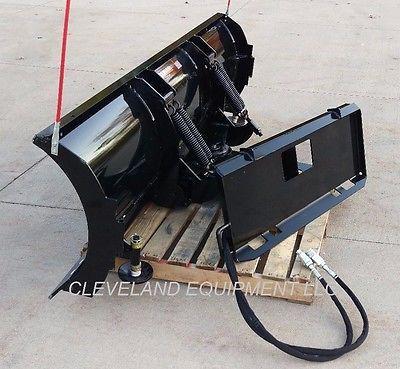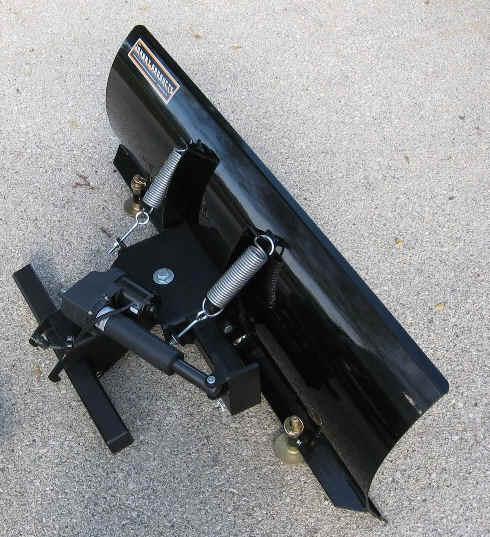The first image is the image on the left, the second image is the image on the right. Analyze the images presented: Is the assertion "The photo on the right shows a snow plow that is not connected to a vehicle and lying on pavement." valid? Answer yes or no. Yes. The first image is the image on the left, the second image is the image on the right. Analyze the images presented: Is the assertion "In one image, a black snowplow blade is attached to the front of a vehicle." valid? Answer yes or no. No. 